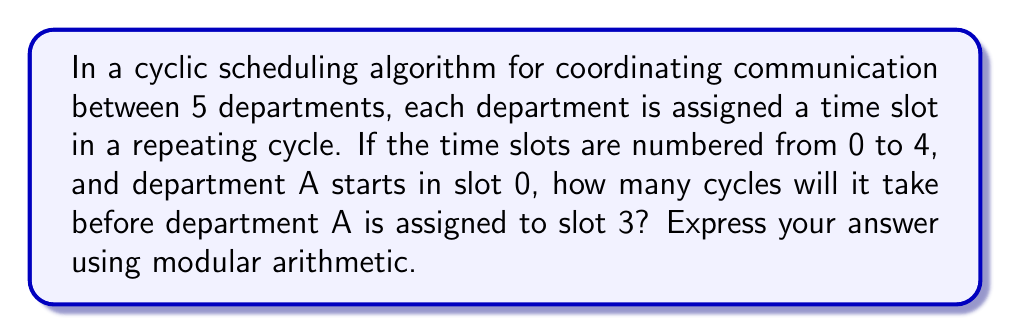Can you solve this math problem? Let's approach this step-by-step using modular arithmetic:

1) We have 5 departments, so we're working in mod 5.

2) Department A starts in slot 0.

3) In each cycle, department A's slot number increases by 1 (mod 5).

4) We want to find how many cycles it takes to reach slot 3.

5) Mathematically, we're solving the congruence:
   $$ x \equiv 3 \pmod{5} $$
   where $x$ is the number of cycles.

6) This is equivalent to solving:
   $$ 0 + x \equiv 3 \pmod{5} $$

7) The solution to this is $x \equiv 3 \pmod{5}$

8) This means after 3 cycles, department A will be in slot 3.

We can verify:
- After 1 cycle: $(0 + 1) \bmod 5 = 1$
- After 2 cycles: $(0 + 2) \bmod 5 = 2$
- After 3 cycles: $(0 + 3) \bmod 5 = 3$

Thus, it takes 3 cycles for department A to reach slot 3.
Answer: $3 \pmod{5}$ 